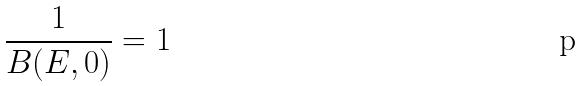<formula> <loc_0><loc_0><loc_500><loc_500>\frac { 1 } { B ( E , 0 ) } = 1</formula> 